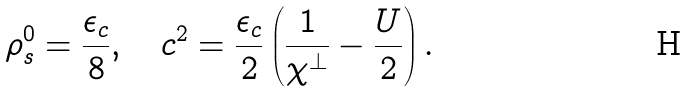Convert formula to latex. <formula><loc_0><loc_0><loc_500><loc_500>\rho _ { s } ^ { 0 } = \frac { \epsilon _ { c } } { 8 } , \quad c ^ { 2 } = \frac { \epsilon _ { c } } { 2 } \left ( \frac { 1 } { \chi ^ { \perp } } - \frac { U } { 2 } \right ) .</formula> 